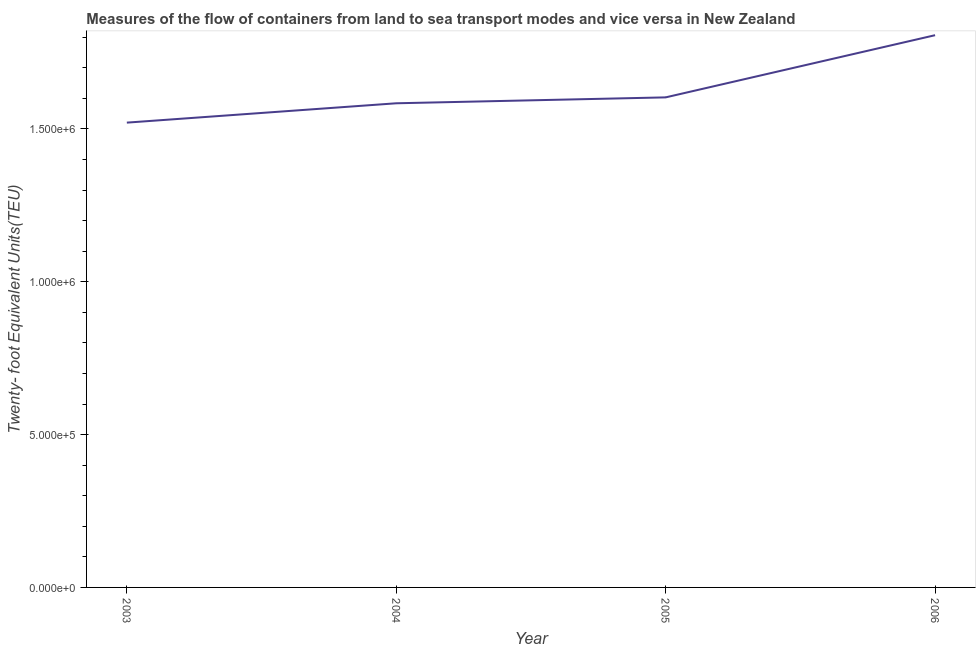What is the container port traffic in 2003?
Ensure brevity in your answer.  1.52e+06. Across all years, what is the maximum container port traffic?
Keep it short and to the point. 1.81e+06. Across all years, what is the minimum container port traffic?
Provide a succinct answer. 1.52e+06. In which year was the container port traffic minimum?
Provide a succinct answer. 2003. What is the sum of the container port traffic?
Your answer should be compact. 6.51e+06. What is the difference between the container port traffic in 2004 and 2005?
Keep it short and to the point. -1.93e+04. What is the average container port traffic per year?
Make the answer very short. 1.63e+06. What is the median container port traffic?
Ensure brevity in your answer.  1.59e+06. Do a majority of the years between 2003 and 2005 (inclusive) have container port traffic greater than 1200000 TEU?
Offer a terse response. Yes. What is the ratio of the container port traffic in 2004 to that in 2006?
Your answer should be very brief. 0.88. Is the container port traffic in 2003 less than that in 2006?
Ensure brevity in your answer.  Yes. Is the difference between the container port traffic in 2003 and 2005 greater than the difference between any two years?
Give a very brief answer. No. What is the difference between the highest and the second highest container port traffic?
Keep it short and to the point. 2.03e+05. What is the difference between the highest and the lowest container port traffic?
Give a very brief answer. 2.86e+05. In how many years, is the container port traffic greater than the average container port traffic taken over all years?
Offer a very short reply. 1. Does the container port traffic monotonically increase over the years?
Provide a short and direct response. Yes. How many lines are there?
Give a very brief answer. 1. How many years are there in the graph?
Give a very brief answer. 4. What is the difference between two consecutive major ticks on the Y-axis?
Your answer should be very brief. 5.00e+05. Are the values on the major ticks of Y-axis written in scientific E-notation?
Your answer should be very brief. Yes. Does the graph contain any zero values?
Give a very brief answer. No. Does the graph contain grids?
Keep it short and to the point. No. What is the title of the graph?
Offer a very short reply. Measures of the flow of containers from land to sea transport modes and vice versa in New Zealand. What is the label or title of the Y-axis?
Offer a very short reply. Twenty- foot Equivalent Units(TEU). What is the Twenty- foot Equivalent Units(TEU) in 2003?
Provide a succinct answer. 1.52e+06. What is the Twenty- foot Equivalent Units(TEU) of 2004?
Give a very brief answer. 1.58e+06. What is the Twenty- foot Equivalent Units(TEU) in 2005?
Your answer should be very brief. 1.60e+06. What is the Twenty- foot Equivalent Units(TEU) in 2006?
Give a very brief answer. 1.81e+06. What is the difference between the Twenty- foot Equivalent Units(TEU) in 2003 and 2004?
Make the answer very short. -6.33e+04. What is the difference between the Twenty- foot Equivalent Units(TEU) in 2003 and 2005?
Your answer should be compact. -8.26e+04. What is the difference between the Twenty- foot Equivalent Units(TEU) in 2003 and 2006?
Your answer should be very brief. -2.86e+05. What is the difference between the Twenty- foot Equivalent Units(TEU) in 2004 and 2005?
Give a very brief answer. -1.93e+04. What is the difference between the Twenty- foot Equivalent Units(TEU) in 2004 and 2006?
Make the answer very short. -2.23e+05. What is the difference between the Twenty- foot Equivalent Units(TEU) in 2005 and 2006?
Provide a short and direct response. -2.03e+05. What is the ratio of the Twenty- foot Equivalent Units(TEU) in 2003 to that in 2005?
Your response must be concise. 0.95. What is the ratio of the Twenty- foot Equivalent Units(TEU) in 2003 to that in 2006?
Your response must be concise. 0.84. What is the ratio of the Twenty- foot Equivalent Units(TEU) in 2004 to that in 2006?
Keep it short and to the point. 0.88. What is the ratio of the Twenty- foot Equivalent Units(TEU) in 2005 to that in 2006?
Offer a very short reply. 0.89. 